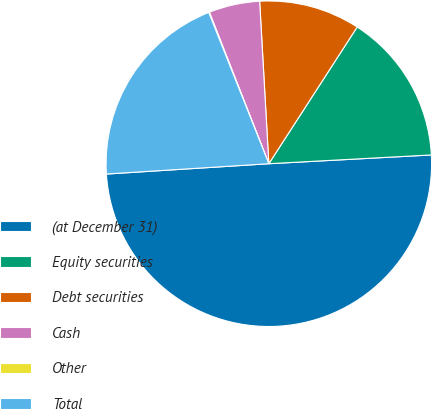<chart> <loc_0><loc_0><loc_500><loc_500><pie_chart><fcel>(at December 31)<fcel>Equity securities<fcel>Debt securities<fcel>Cash<fcel>Other<fcel>Total<nl><fcel>49.85%<fcel>15.01%<fcel>10.03%<fcel>5.05%<fcel>0.07%<fcel>19.99%<nl></chart> 